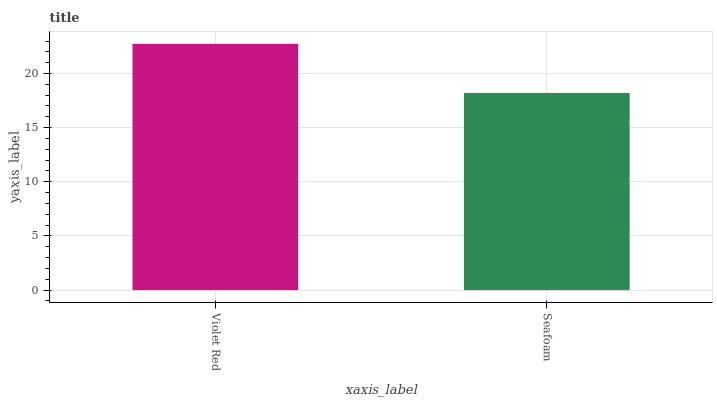Is Seafoam the minimum?
Answer yes or no. Yes. Is Violet Red the maximum?
Answer yes or no. Yes. Is Seafoam the maximum?
Answer yes or no. No. Is Violet Red greater than Seafoam?
Answer yes or no. Yes. Is Seafoam less than Violet Red?
Answer yes or no. Yes. Is Seafoam greater than Violet Red?
Answer yes or no. No. Is Violet Red less than Seafoam?
Answer yes or no. No. Is Violet Red the high median?
Answer yes or no. Yes. Is Seafoam the low median?
Answer yes or no. Yes. Is Seafoam the high median?
Answer yes or no. No. Is Violet Red the low median?
Answer yes or no. No. 